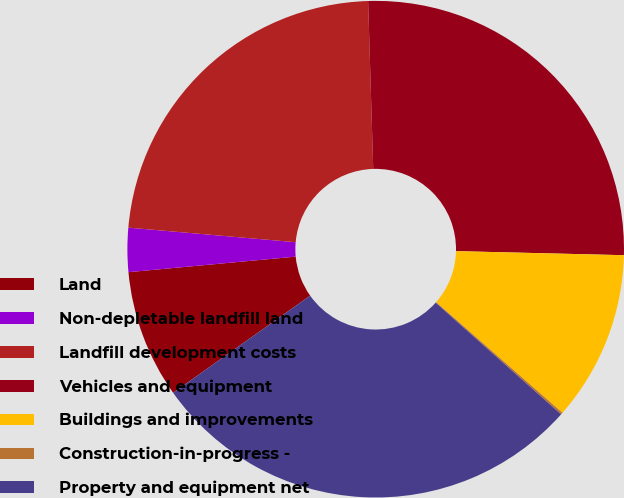Convert chart to OTSL. <chart><loc_0><loc_0><loc_500><loc_500><pie_chart><fcel>Land<fcel>Non-depletable landfill land<fcel>Landfill development costs<fcel>Vehicles and equipment<fcel>Buildings and improvements<fcel>Construction-in-progress -<fcel>Property and equipment net<nl><fcel>8.34%<fcel>2.86%<fcel>23.13%<fcel>25.87%<fcel>11.07%<fcel>0.13%<fcel>28.6%<nl></chart> 